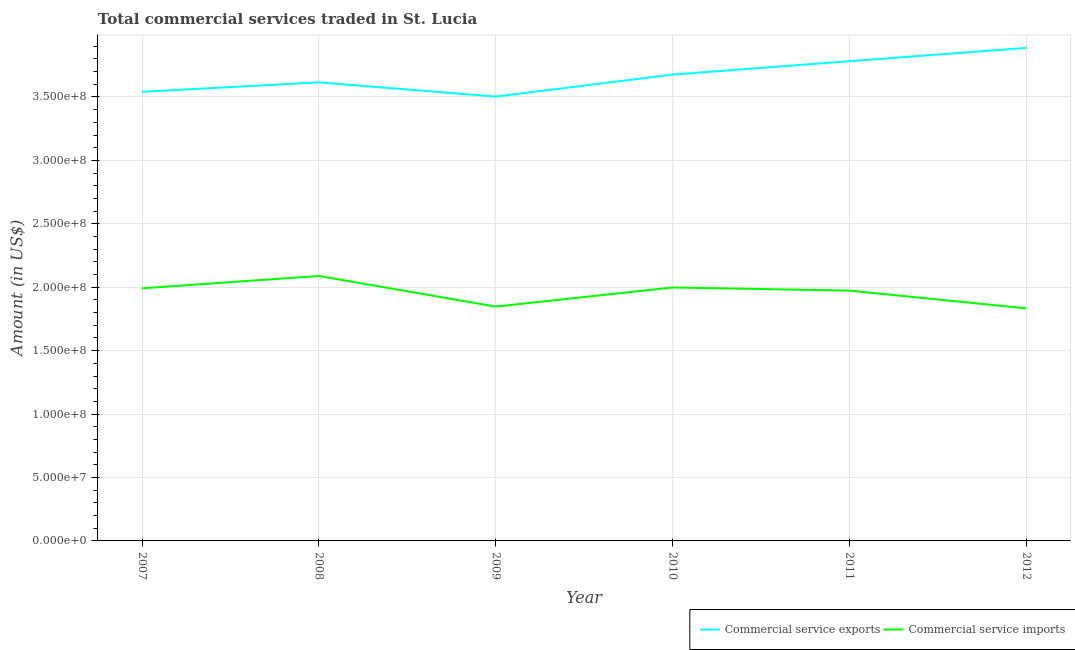How many different coloured lines are there?
Provide a short and direct response. 2. What is the amount of commercial service imports in 2008?
Your answer should be compact. 2.09e+08. Across all years, what is the maximum amount of commercial service exports?
Offer a very short reply. 3.89e+08. Across all years, what is the minimum amount of commercial service imports?
Keep it short and to the point. 1.83e+08. In which year was the amount of commercial service imports minimum?
Ensure brevity in your answer.  2012. What is the total amount of commercial service imports in the graph?
Provide a succinct answer. 1.17e+09. What is the difference between the amount of commercial service exports in 2007 and that in 2012?
Make the answer very short. -3.46e+07. What is the difference between the amount of commercial service exports in 2008 and the amount of commercial service imports in 2009?
Ensure brevity in your answer.  1.77e+08. What is the average amount of commercial service imports per year?
Your answer should be compact. 1.96e+08. In the year 2010, what is the difference between the amount of commercial service imports and amount of commercial service exports?
Make the answer very short. -1.68e+08. What is the ratio of the amount of commercial service imports in 2009 to that in 2011?
Provide a short and direct response. 0.94. Is the amount of commercial service exports in 2007 less than that in 2008?
Provide a short and direct response. Yes. Is the difference between the amount of commercial service exports in 2010 and 2011 greater than the difference between the amount of commercial service imports in 2010 and 2011?
Give a very brief answer. No. What is the difference between the highest and the second highest amount of commercial service imports?
Provide a succinct answer. 9.05e+06. What is the difference between the highest and the lowest amount of commercial service imports?
Your answer should be very brief. 2.55e+07. Is the amount of commercial service imports strictly greater than the amount of commercial service exports over the years?
Offer a very short reply. No. How many lines are there?
Make the answer very short. 2. How many years are there in the graph?
Give a very brief answer. 6. Are the values on the major ticks of Y-axis written in scientific E-notation?
Make the answer very short. Yes. How many legend labels are there?
Your response must be concise. 2. How are the legend labels stacked?
Your response must be concise. Horizontal. What is the title of the graph?
Offer a terse response. Total commercial services traded in St. Lucia. What is the Amount (in US$) in Commercial service exports in 2007?
Provide a succinct answer. 3.54e+08. What is the Amount (in US$) of Commercial service imports in 2007?
Ensure brevity in your answer.  1.99e+08. What is the Amount (in US$) in Commercial service exports in 2008?
Offer a terse response. 3.62e+08. What is the Amount (in US$) of Commercial service imports in 2008?
Offer a very short reply. 2.09e+08. What is the Amount (in US$) in Commercial service exports in 2009?
Your answer should be compact. 3.50e+08. What is the Amount (in US$) in Commercial service imports in 2009?
Give a very brief answer. 1.85e+08. What is the Amount (in US$) in Commercial service exports in 2010?
Provide a short and direct response. 3.68e+08. What is the Amount (in US$) of Commercial service imports in 2010?
Your response must be concise. 2.00e+08. What is the Amount (in US$) in Commercial service exports in 2011?
Make the answer very short. 3.78e+08. What is the Amount (in US$) of Commercial service imports in 2011?
Offer a very short reply. 1.97e+08. What is the Amount (in US$) of Commercial service exports in 2012?
Offer a terse response. 3.89e+08. What is the Amount (in US$) in Commercial service imports in 2012?
Provide a succinct answer. 1.83e+08. Across all years, what is the maximum Amount (in US$) in Commercial service exports?
Ensure brevity in your answer.  3.89e+08. Across all years, what is the maximum Amount (in US$) in Commercial service imports?
Offer a very short reply. 2.09e+08. Across all years, what is the minimum Amount (in US$) of Commercial service exports?
Your answer should be compact. 3.50e+08. Across all years, what is the minimum Amount (in US$) of Commercial service imports?
Give a very brief answer. 1.83e+08. What is the total Amount (in US$) of Commercial service exports in the graph?
Ensure brevity in your answer.  2.20e+09. What is the total Amount (in US$) of Commercial service imports in the graph?
Your response must be concise. 1.17e+09. What is the difference between the Amount (in US$) of Commercial service exports in 2007 and that in 2008?
Ensure brevity in your answer.  -7.46e+06. What is the difference between the Amount (in US$) in Commercial service imports in 2007 and that in 2008?
Give a very brief answer. -9.71e+06. What is the difference between the Amount (in US$) of Commercial service exports in 2007 and that in 2009?
Give a very brief answer. 3.79e+06. What is the difference between the Amount (in US$) of Commercial service imports in 2007 and that in 2009?
Your response must be concise. 1.44e+07. What is the difference between the Amount (in US$) of Commercial service exports in 2007 and that in 2010?
Give a very brief answer. -1.36e+07. What is the difference between the Amount (in US$) of Commercial service imports in 2007 and that in 2010?
Provide a succinct answer. -6.63e+05. What is the difference between the Amount (in US$) in Commercial service exports in 2007 and that in 2011?
Your response must be concise. -2.41e+07. What is the difference between the Amount (in US$) in Commercial service imports in 2007 and that in 2011?
Your answer should be very brief. 1.82e+06. What is the difference between the Amount (in US$) in Commercial service exports in 2007 and that in 2012?
Make the answer very short. -3.46e+07. What is the difference between the Amount (in US$) of Commercial service imports in 2007 and that in 2012?
Ensure brevity in your answer.  1.58e+07. What is the difference between the Amount (in US$) in Commercial service exports in 2008 and that in 2009?
Provide a short and direct response. 1.12e+07. What is the difference between the Amount (in US$) in Commercial service imports in 2008 and that in 2009?
Make the answer very short. 2.41e+07. What is the difference between the Amount (in US$) of Commercial service exports in 2008 and that in 2010?
Give a very brief answer. -6.13e+06. What is the difference between the Amount (in US$) in Commercial service imports in 2008 and that in 2010?
Provide a short and direct response. 9.05e+06. What is the difference between the Amount (in US$) of Commercial service exports in 2008 and that in 2011?
Your answer should be compact. -1.67e+07. What is the difference between the Amount (in US$) in Commercial service imports in 2008 and that in 2011?
Make the answer very short. 1.15e+07. What is the difference between the Amount (in US$) in Commercial service exports in 2008 and that in 2012?
Make the answer very short. -2.72e+07. What is the difference between the Amount (in US$) in Commercial service imports in 2008 and that in 2012?
Your response must be concise. 2.55e+07. What is the difference between the Amount (in US$) in Commercial service exports in 2009 and that in 2010?
Provide a succinct answer. -1.74e+07. What is the difference between the Amount (in US$) of Commercial service imports in 2009 and that in 2010?
Provide a succinct answer. -1.51e+07. What is the difference between the Amount (in US$) of Commercial service exports in 2009 and that in 2011?
Offer a very short reply. -2.79e+07. What is the difference between the Amount (in US$) in Commercial service imports in 2009 and that in 2011?
Make the answer very short. -1.26e+07. What is the difference between the Amount (in US$) of Commercial service exports in 2009 and that in 2012?
Offer a very short reply. -3.84e+07. What is the difference between the Amount (in US$) of Commercial service imports in 2009 and that in 2012?
Your answer should be very brief. 1.40e+06. What is the difference between the Amount (in US$) in Commercial service exports in 2010 and that in 2011?
Your answer should be compact. -1.05e+07. What is the difference between the Amount (in US$) in Commercial service imports in 2010 and that in 2011?
Give a very brief answer. 2.48e+06. What is the difference between the Amount (in US$) in Commercial service exports in 2010 and that in 2012?
Make the answer very short. -2.10e+07. What is the difference between the Amount (in US$) in Commercial service imports in 2010 and that in 2012?
Offer a very short reply. 1.65e+07. What is the difference between the Amount (in US$) of Commercial service exports in 2011 and that in 2012?
Offer a very short reply. -1.05e+07. What is the difference between the Amount (in US$) in Commercial service imports in 2011 and that in 2012?
Give a very brief answer. 1.40e+07. What is the difference between the Amount (in US$) of Commercial service exports in 2007 and the Amount (in US$) of Commercial service imports in 2008?
Your answer should be compact. 1.45e+08. What is the difference between the Amount (in US$) in Commercial service exports in 2007 and the Amount (in US$) in Commercial service imports in 2009?
Make the answer very short. 1.69e+08. What is the difference between the Amount (in US$) of Commercial service exports in 2007 and the Amount (in US$) of Commercial service imports in 2010?
Your answer should be compact. 1.54e+08. What is the difference between the Amount (in US$) in Commercial service exports in 2007 and the Amount (in US$) in Commercial service imports in 2011?
Provide a succinct answer. 1.57e+08. What is the difference between the Amount (in US$) of Commercial service exports in 2007 and the Amount (in US$) of Commercial service imports in 2012?
Your answer should be very brief. 1.71e+08. What is the difference between the Amount (in US$) in Commercial service exports in 2008 and the Amount (in US$) in Commercial service imports in 2009?
Your answer should be very brief. 1.77e+08. What is the difference between the Amount (in US$) of Commercial service exports in 2008 and the Amount (in US$) of Commercial service imports in 2010?
Offer a very short reply. 1.62e+08. What is the difference between the Amount (in US$) in Commercial service exports in 2008 and the Amount (in US$) in Commercial service imports in 2011?
Offer a very short reply. 1.64e+08. What is the difference between the Amount (in US$) in Commercial service exports in 2008 and the Amount (in US$) in Commercial service imports in 2012?
Your answer should be compact. 1.78e+08. What is the difference between the Amount (in US$) of Commercial service exports in 2009 and the Amount (in US$) of Commercial service imports in 2010?
Keep it short and to the point. 1.50e+08. What is the difference between the Amount (in US$) of Commercial service exports in 2009 and the Amount (in US$) of Commercial service imports in 2011?
Offer a very short reply. 1.53e+08. What is the difference between the Amount (in US$) in Commercial service exports in 2009 and the Amount (in US$) in Commercial service imports in 2012?
Provide a short and direct response. 1.67e+08. What is the difference between the Amount (in US$) in Commercial service exports in 2010 and the Amount (in US$) in Commercial service imports in 2011?
Ensure brevity in your answer.  1.70e+08. What is the difference between the Amount (in US$) of Commercial service exports in 2010 and the Amount (in US$) of Commercial service imports in 2012?
Provide a short and direct response. 1.84e+08. What is the difference between the Amount (in US$) of Commercial service exports in 2011 and the Amount (in US$) of Commercial service imports in 2012?
Your answer should be compact. 1.95e+08. What is the average Amount (in US$) of Commercial service exports per year?
Your answer should be compact. 3.67e+08. What is the average Amount (in US$) in Commercial service imports per year?
Ensure brevity in your answer.  1.96e+08. In the year 2007, what is the difference between the Amount (in US$) of Commercial service exports and Amount (in US$) of Commercial service imports?
Your answer should be very brief. 1.55e+08. In the year 2008, what is the difference between the Amount (in US$) of Commercial service exports and Amount (in US$) of Commercial service imports?
Offer a very short reply. 1.53e+08. In the year 2009, what is the difference between the Amount (in US$) in Commercial service exports and Amount (in US$) in Commercial service imports?
Your answer should be very brief. 1.66e+08. In the year 2010, what is the difference between the Amount (in US$) of Commercial service exports and Amount (in US$) of Commercial service imports?
Make the answer very short. 1.68e+08. In the year 2011, what is the difference between the Amount (in US$) of Commercial service exports and Amount (in US$) of Commercial service imports?
Your response must be concise. 1.81e+08. In the year 2012, what is the difference between the Amount (in US$) in Commercial service exports and Amount (in US$) in Commercial service imports?
Keep it short and to the point. 2.05e+08. What is the ratio of the Amount (in US$) in Commercial service exports in 2007 to that in 2008?
Offer a terse response. 0.98. What is the ratio of the Amount (in US$) of Commercial service imports in 2007 to that in 2008?
Provide a short and direct response. 0.95. What is the ratio of the Amount (in US$) of Commercial service exports in 2007 to that in 2009?
Your response must be concise. 1.01. What is the ratio of the Amount (in US$) in Commercial service imports in 2007 to that in 2009?
Provide a succinct answer. 1.08. What is the ratio of the Amount (in US$) in Commercial service exports in 2007 to that in 2010?
Keep it short and to the point. 0.96. What is the ratio of the Amount (in US$) in Commercial service exports in 2007 to that in 2011?
Provide a succinct answer. 0.94. What is the ratio of the Amount (in US$) of Commercial service imports in 2007 to that in 2011?
Offer a terse response. 1.01. What is the ratio of the Amount (in US$) in Commercial service exports in 2007 to that in 2012?
Provide a short and direct response. 0.91. What is the ratio of the Amount (in US$) in Commercial service imports in 2007 to that in 2012?
Your response must be concise. 1.09. What is the ratio of the Amount (in US$) in Commercial service exports in 2008 to that in 2009?
Offer a terse response. 1.03. What is the ratio of the Amount (in US$) in Commercial service imports in 2008 to that in 2009?
Give a very brief answer. 1.13. What is the ratio of the Amount (in US$) of Commercial service exports in 2008 to that in 2010?
Offer a very short reply. 0.98. What is the ratio of the Amount (in US$) of Commercial service imports in 2008 to that in 2010?
Make the answer very short. 1.05. What is the ratio of the Amount (in US$) in Commercial service exports in 2008 to that in 2011?
Make the answer very short. 0.96. What is the ratio of the Amount (in US$) in Commercial service imports in 2008 to that in 2011?
Provide a succinct answer. 1.06. What is the ratio of the Amount (in US$) of Commercial service exports in 2008 to that in 2012?
Provide a succinct answer. 0.93. What is the ratio of the Amount (in US$) of Commercial service imports in 2008 to that in 2012?
Offer a very short reply. 1.14. What is the ratio of the Amount (in US$) of Commercial service exports in 2009 to that in 2010?
Provide a short and direct response. 0.95. What is the ratio of the Amount (in US$) in Commercial service imports in 2009 to that in 2010?
Give a very brief answer. 0.92. What is the ratio of the Amount (in US$) in Commercial service exports in 2009 to that in 2011?
Offer a very short reply. 0.93. What is the ratio of the Amount (in US$) of Commercial service imports in 2009 to that in 2011?
Make the answer very short. 0.94. What is the ratio of the Amount (in US$) of Commercial service exports in 2009 to that in 2012?
Offer a terse response. 0.9. What is the ratio of the Amount (in US$) of Commercial service imports in 2009 to that in 2012?
Provide a short and direct response. 1.01. What is the ratio of the Amount (in US$) in Commercial service exports in 2010 to that in 2011?
Give a very brief answer. 0.97. What is the ratio of the Amount (in US$) of Commercial service imports in 2010 to that in 2011?
Your answer should be compact. 1.01. What is the ratio of the Amount (in US$) of Commercial service exports in 2010 to that in 2012?
Provide a short and direct response. 0.95. What is the ratio of the Amount (in US$) in Commercial service imports in 2010 to that in 2012?
Provide a short and direct response. 1.09. What is the ratio of the Amount (in US$) in Commercial service imports in 2011 to that in 2012?
Offer a very short reply. 1.08. What is the difference between the highest and the second highest Amount (in US$) in Commercial service exports?
Provide a succinct answer. 1.05e+07. What is the difference between the highest and the second highest Amount (in US$) in Commercial service imports?
Provide a short and direct response. 9.05e+06. What is the difference between the highest and the lowest Amount (in US$) of Commercial service exports?
Your response must be concise. 3.84e+07. What is the difference between the highest and the lowest Amount (in US$) of Commercial service imports?
Offer a very short reply. 2.55e+07. 